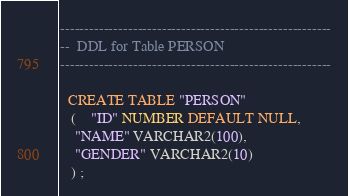<code> <loc_0><loc_0><loc_500><loc_500><_SQL_>--------------------------------------------------------
--  DDL for Table PERSON
--------------------------------------------------------

  CREATE TABLE "PERSON" 
   (	"ID" NUMBER DEFAULT NULL, 
	"NAME" VARCHAR2(100), 
	"GENDER" VARCHAR2(10)
   ) ;
</code> 